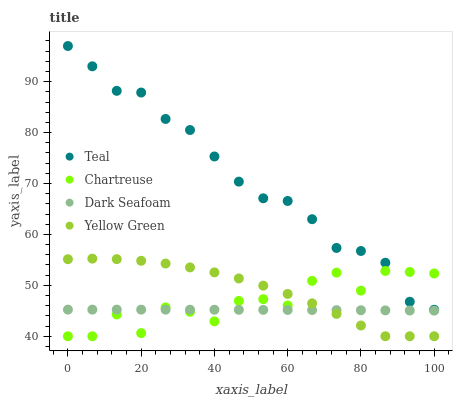Does Dark Seafoam have the minimum area under the curve?
Answer yes or no. Yes. Does Teal have the maximum area under the curve?
Answer yes or no. Yes. Does Teal have the minimum area under the curve?
Answer yes or no. No. Does Dark Seafoam have the maximum area under the curve?
Answer yes or no. No. Is Dark Seafoam the smoothest?
Answer yes or no. Yes. Is Chartreuse the roughest?
Answer yes or no. Yes. Is Teal the smoothest?
Answer yes or no. No. Is Teal the roughest?
Answer yes or no. No. Does Chartreuse have the lowest value?
Answer yes or no. Yes. Does Dark Seafoam have the lowest value?
Answer yes or no. No. Does Teal have the highest value?
Answer yes or no. Yes. Does Dark Seafoam have the highest value?
Answer yes or no. No. Is Yellow Green less than Teal?
Answer yes or no. Yes. Is Teal greater than Yellow Green?
Answer yes or no. Yes. Does Dark Seafoam intersect Yellow Green?
Answer yes or no. Yes. Is Dark Seafoam less than Yellow Green?
Answer yes or no. No. Is Dark Seafoam greater than Yellow Green?
Answer yes or no. No. Does Yellow Green intersect Teal?
Answer yes or no. No. 